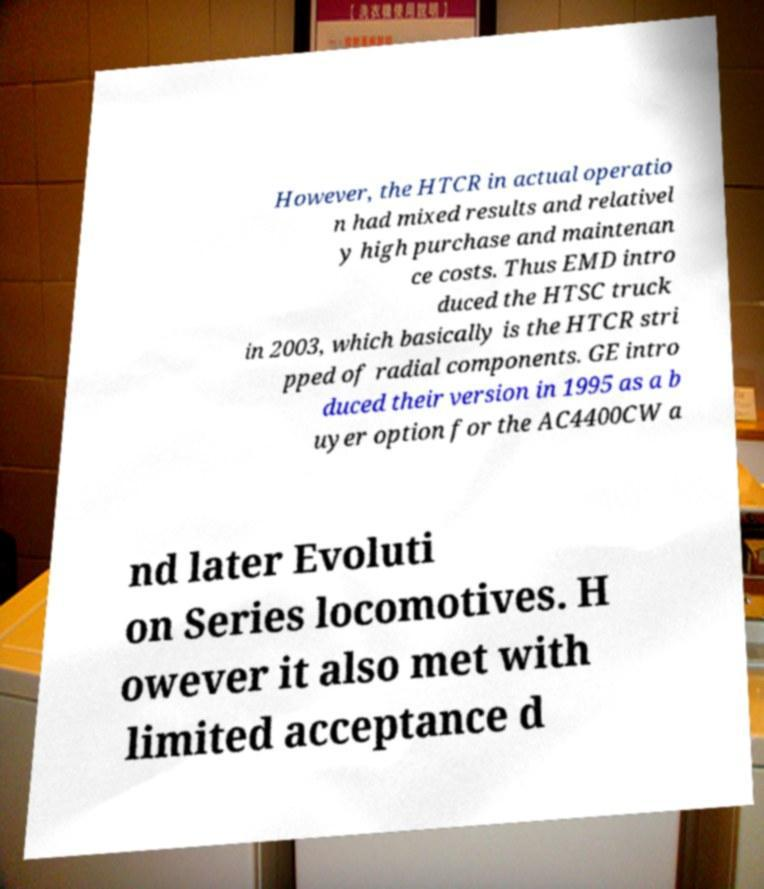For documentation purposes, I need the text within this image transcribed. Could you provide that? However, the HTCR in actual operatio n had mixed results and relativel y high purchase and maintenan ce costs. Thus EMD intro duced the HTSC truck in 2003, which basically is the HTCR stri pped of radial components. GE intro duced their version in 1995 as a b uyer option for the AC4400CW a nd later Evoluti on Series locomotives. H owever it also met with limited acceptance d 